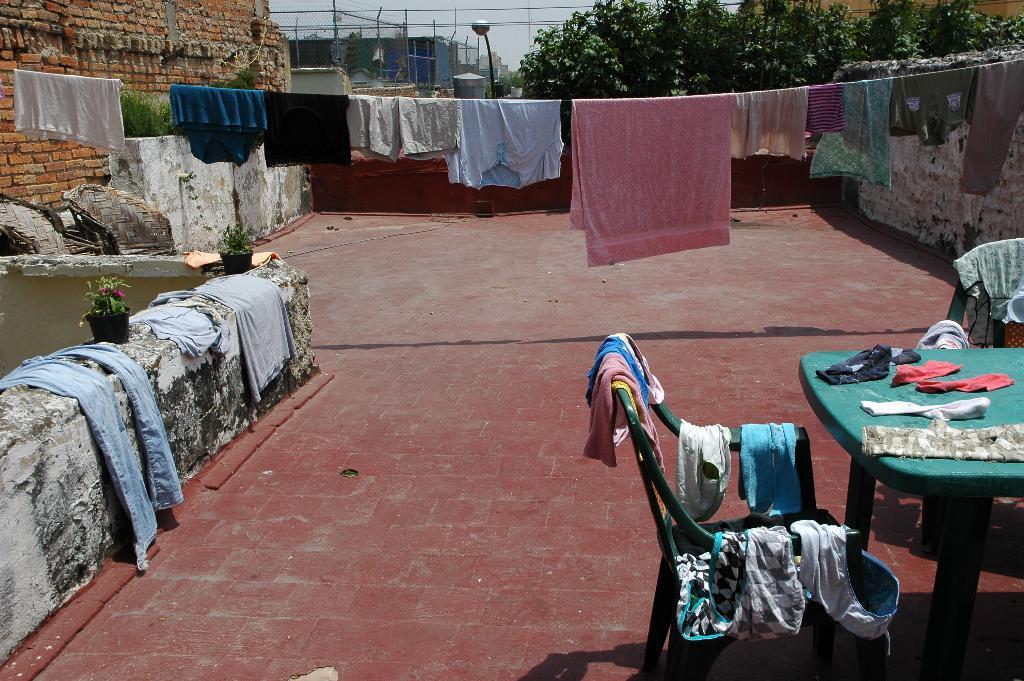How would you summarize this image in a sentence or two? This picture is taken on the top of a building. In the foreground of the picture there is a table and chairs, on the table and chair there are clothes. On the left there is a wall on the wall there are clothes and flower pots. In the center of the picture there is a wire, on the wire there are clothes. On the top left there is a brick wall. on the top right there are trees. In the center of the background there is a street light and fencing and building. Floor is in red color. 